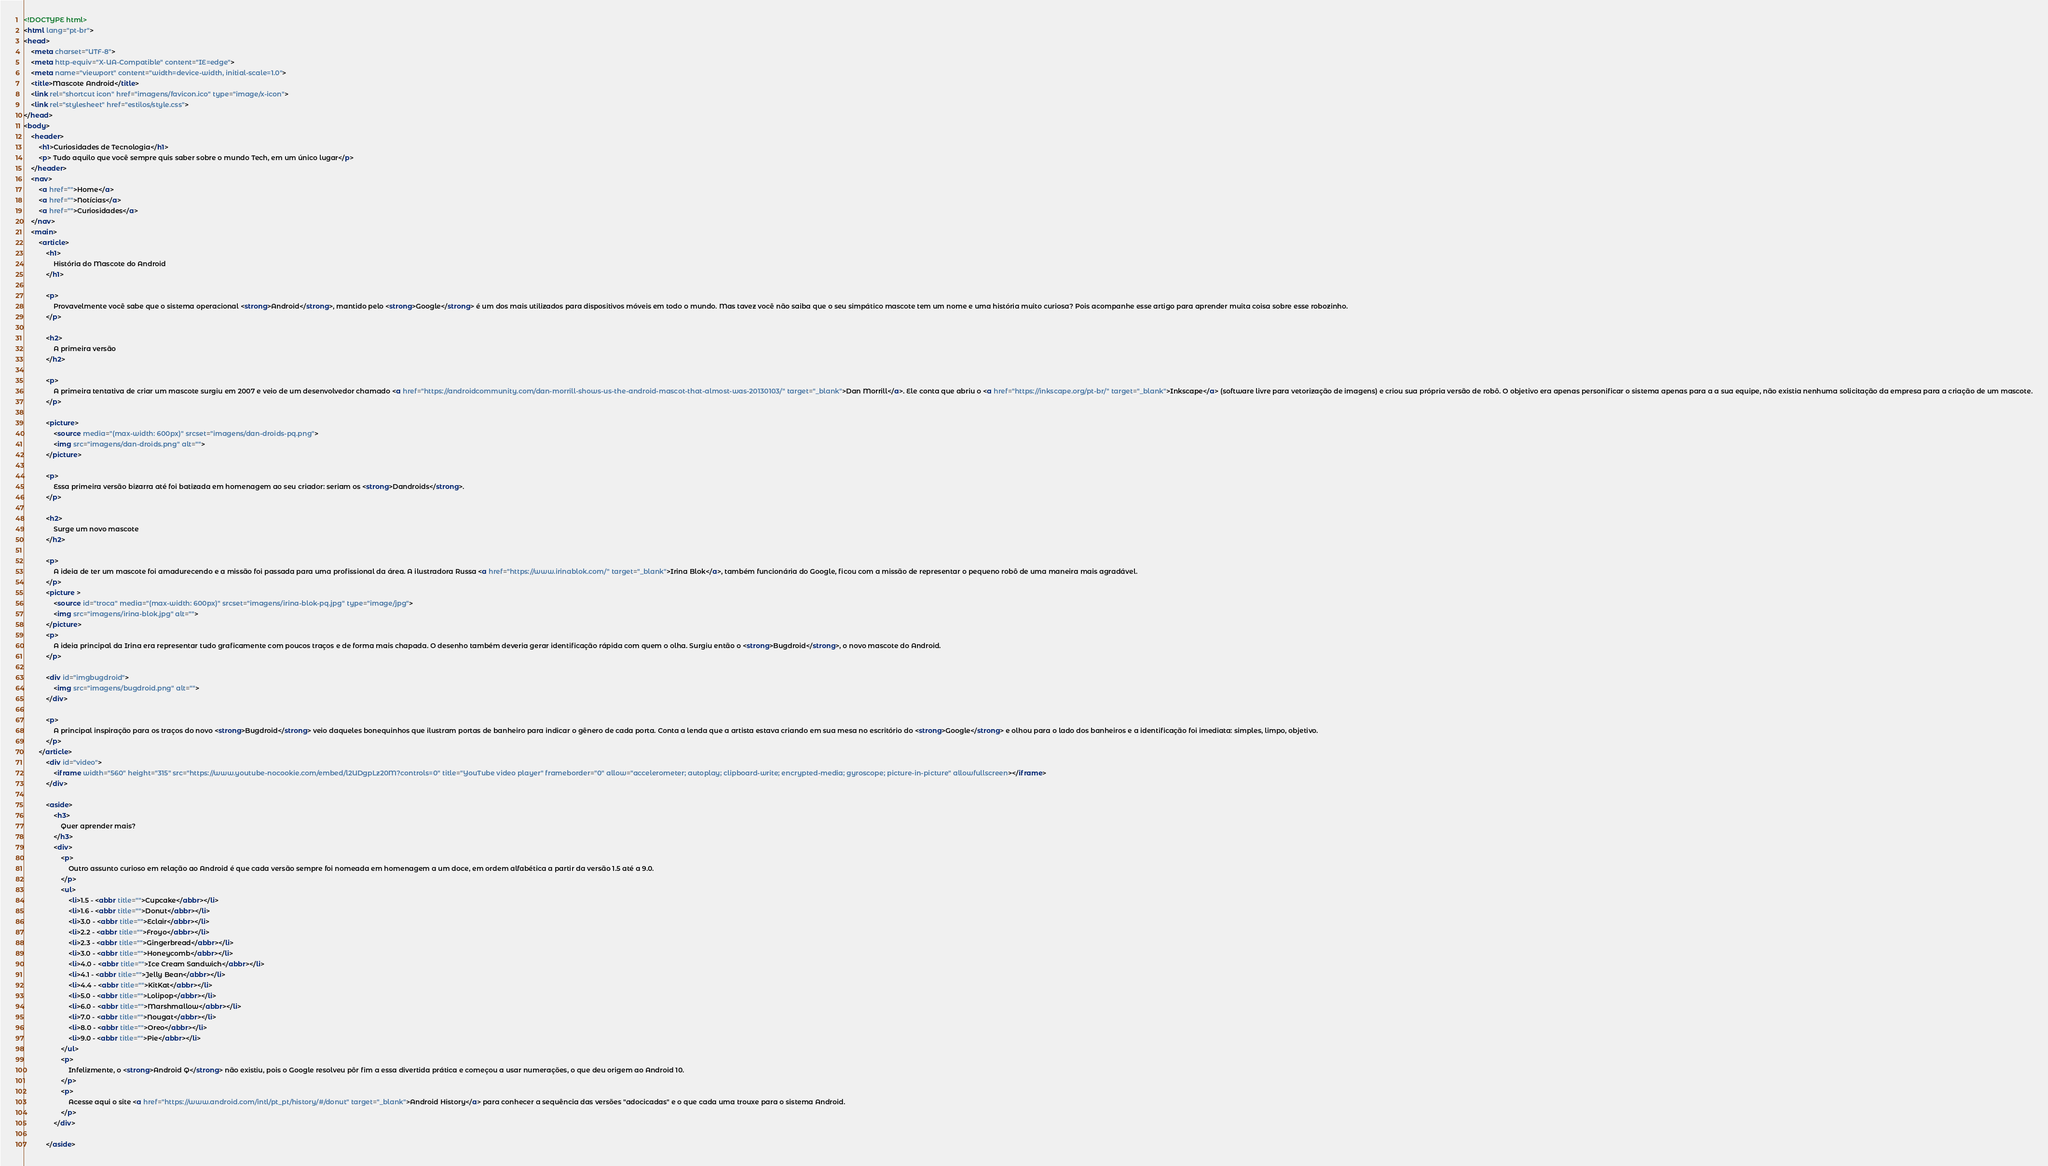Convert code to text. <code><loc_0><loc_0><loc_500><loc_500><_HTML_><!DOCTYPE html>
<html lang="pt-br">
<head>
    <meta charset="UTF-8">
    <meta http-equiv="X-UA-Compatible" content="IE=edge">
    <meta name="viewport" content="width=device-width, initial-scale=1.0">
    <title>Mascote Android</title>
    <link rel="shortcut icon" href="imagens/favicon.ico" type="image/x-icon">
    <link rel="stylesheet" href="estilos/style.css">
</head>
<body>
    <header>
        <h1>Curiosidades de Tecnologia</h1>
        <p> Tudo aquilo que você sempre quis saber sobre o mundo Tech, em um único lugar</p>
    </header>
    <nav>
        <a href="">Home</a>
        <a href="">Notícias</a>
        <a href="">Curiosidades</a>
    </nav>
    <main>
        <article>
            <h1>
                História do Mascote do Android
            </h1>

            <p>
                Provavelmente você sabe que o sistema operacional <strong>Android</strong>, mantido pelo <strong>Google</strong> é um dos mais utilizados para dispositivos móveis em todo o mundo. Mas tavez você não saiba que o seu simpático mascote tem um nome e uma história muito curiosa? Pois acompanhe esse artigo para aprender muita coisa sobre esse robozinho.
            </p>

            <h2>
                A primeira versão
            </h2>

            <p>
                A primeira tentativa de criar um mascote surgiu em 2007 e veio de um desenvolvedor chamado <a href="https://androidcommunity.com/dan-morrill-shows-us-the-android-mascot-that-almost-was-20130103/" target="_blank">Dan Morrill</a>. Ele conta que abriu o <a href="https://inkscape.org/pt-br/" target="_blank">Inkscape</a> (software livre para vetorização de imagens) e criou sua própria versão de robô. O objetivo era apenas personificar o sistema apenas para a a sua equipe, não existia nenhuma solicitação da empresa para a criação de um mascote.
            </p>

            <picture>
                <source media="(max-width: 600px)" srcset="imagens/dan-droids-pq.png">
                <img src="imagens/dan-droids.png" alt="">
            </picture>

            <p>
                Essa primeira versão bizarra até foi batizada em homenagem ao seu criador: seriam os <strong>Dandroids</strong>.
            </p>

            <h2>
                Surge um novo mascote
            </h2>

            <p>
                A ideia de ter um mascote foi amadurecendo e a missão foi passada para uma profissional da área. A ilustradora Russa <a href="https://www.irinablok.com/" target="_blank">Irina Blok</a>, também funcionária do Google, ficou com a missão de representar o pequeno robô de uma maneira mais agradável.
            </p>
            <picture >  
                <source id="troca" media="(max-width: 600px)" srcset="imagens/irina-blok-pq.jpg" type="image/jpg">
                <img src="imagens/irina-blok.jpg" alt="">
            </picture>
            <p>
                A ideia principal da Irina era representar tudo graficamente com poucos traços e de forma mais chapada. O desenho também deveria gerar identificação rápida com quem o olha. Surgiu então o <strong>Bugdroid</strong>, o novo mascote do Android.
            </p>

            <div id="imgbugdroid">
                <img src="imagens/bugdroid.png" alt="">
            </div>

            <p>
                A principal inspiração para os traços do novo <strong>Bugdroid</strong> veio daqueles bonequinhos que ilustram portas de banheiro para indicar o gênero de cada porta. Conta a lenda que a artista estava criando em sua mesa no escritório do <strong>Google</strong> e olhou para o lado dos banheiros e a identificação foi imediata: simples, limpo, objetivo.
            </p>
        </article>
            <div id="video">
                <iframe width="560" height="315" src="https://www.youtube-nocookie.com/embed/l2UDgpLz20M?controls=0" title="YouTube video player" frameborder="0" allow="accelerometer; autoplay; clipboard-write; encrypted-media; gyroscope; picture-in-picture" allowfullscreen></iframe>
            </div>
            
            <aside>
                <h3>
                    Quer aprender mais?
                </h3>
                <div>
                    <p>
                        Outro assunto curioso em relação ao Android é que cada versão sempre foi nomeada em homenagem a um doce, em ordem alfabética a partir da versão 1.5 até a 9.0.
                    </p>
                    <ul>
                        <li>1.5 - <abbr title="">Cupcake</abbr></li>
                        <li>1.6 - <abbr title="">Donut</abbr></li>
                        <li>3.0 - <abbr title="">Eclair</abbr></li>
                        <li>2.2 - <abbr title="">Froyo</abbr></li>
                        <li>2.3 - <abbr title="">Gingerbread</abbr></li>
                        <li>3.0 - <abbr title="">Honeycomb</abbr></li>
                        <li>4.0 - <abbr title="">Ice Cream Sandwich</abbr></li>
                        <li>4.1 - <abbr title="">Jelly Bean</abbr></li>
                        <li>4.4 - <abbr title="">KitKat</abbr></li>
                        <li>5.0 - <abbr title="">Lolipop</abbr></li>
                        <li>6.0 - <abbr title="">Marshmallow</abbr></li>
                        <li>7.0 - <abbr title="">Nougat</abbr></li>
                        <li>8.0 - <abbr title="">Oreo</abbr></li>
                        <li>9.0 - <abbr title="">Pie</abbr></li>
                    </ul>
                    <p>
                        Infelizmente, o <strong>Android Q</strong> não existiu, pois o Google resolveu pôr fim a essa divertida prática e começou a usar numerações, o que deu origem ao Android 10.
                    </p>
                    <p>
                        Acesse aqui o site <a href="https://www.android.com/intl/pt_pt/history/#/donut" target="_blank">Android History</a> para conhecer a sequência das versões "adocicadas" e o que cada uma trouxe para o sistema Android.
                    </p>
                </div>

            </aside>
</code> 